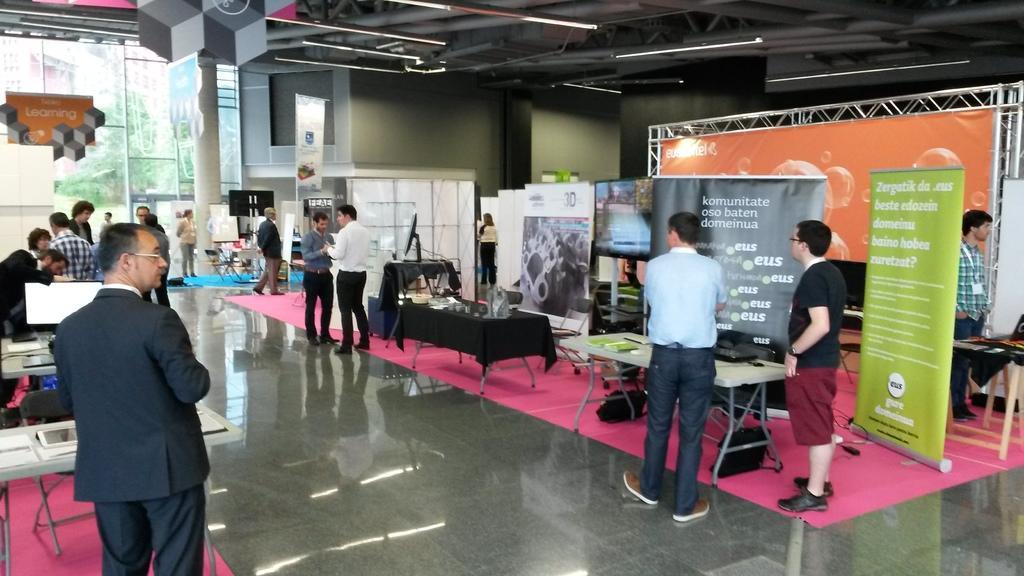How would you summarize this image in a sentence or two? In this image, we can see few people are standing on the floor. Here there are so many tables, few objects are placed on it. Here we can see banners, rods, walls, glass, pillar, lights. Through the glass we can see the outside view. Here we can see trees. 